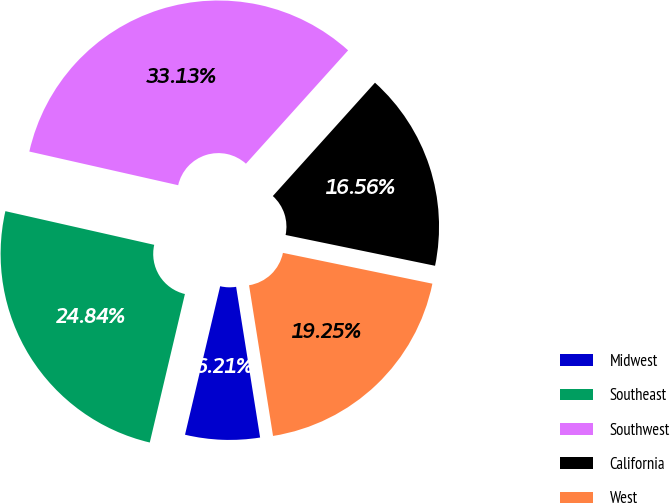<chart> <loc_0><loc_0><loc_500><loc_500><pie_chart><fcel>Midwest<fcel>Southeast<fcel>Southwest<fcel>California<fcel>West<nl><fcel>6.21%<fcel>24.84%<fcel>33.13%<fcel>16.56%<fcel>19.25%<nl></chart> 